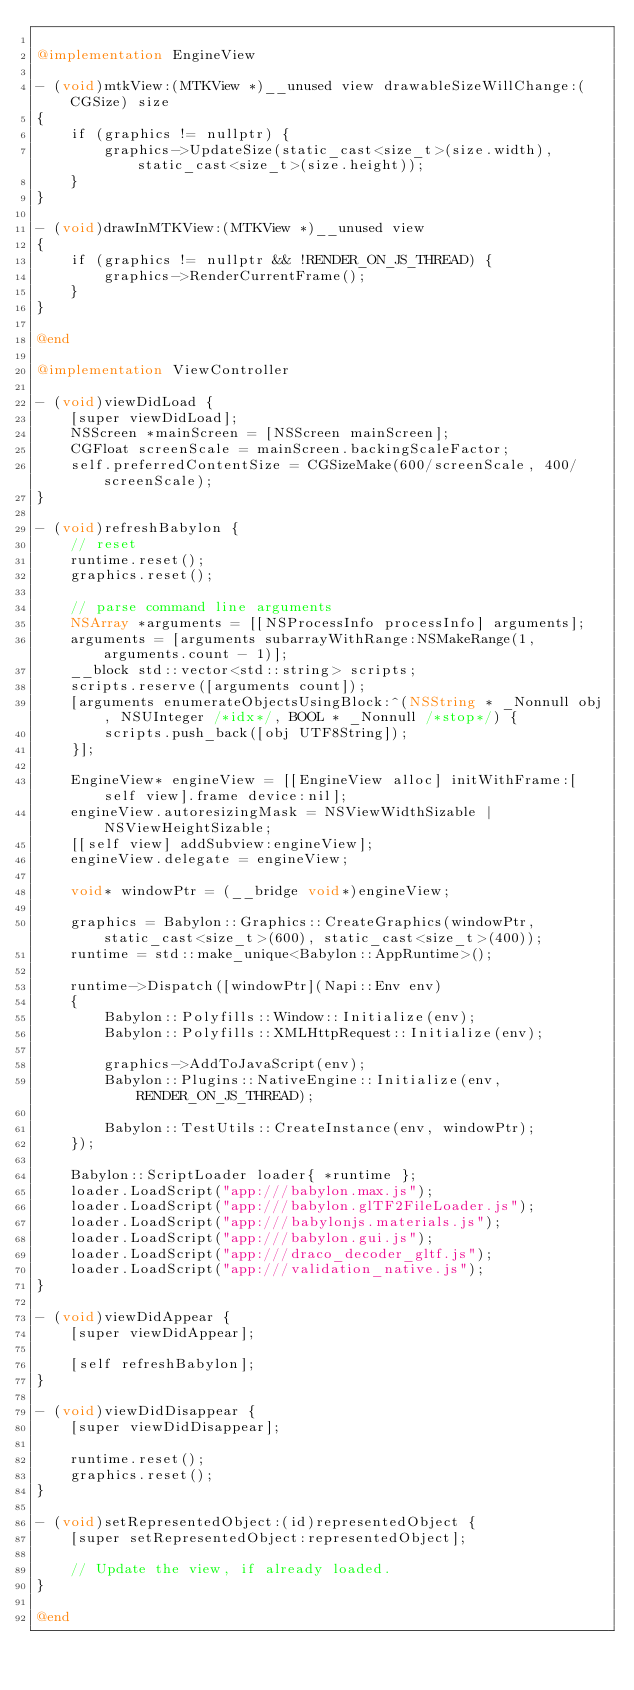<code> <loc_0><loc_0><loc_500><loc_500><_ObjectiveC_>
@implementation EngineView

- (void)mtkView:(MTKView *)__unused view drawableSizeWillChange:(CGSize) size
{
    if (graphics != nullptr) {
        graphics->UpdateSize(static_cast<size_t>(size.width), static_cast<size_t>(size.height));
    }
}

- (void)drawInMTKView:(MTKView *)__unused view
{
    if (graphics != nullptr && !RENDER_ON_JS_THREAD) {
        graphics->RenderCurrentFrame();
    }
}

@end

@implementation ViewController

- (void)viewDidLoad {
    [super viewDidLoad];
    NSScreen *mainScreen = [NSScreen mainScreen];
    CGFloat screenScale = mainScreen.backingScaleFactor;
    self.preferredContentSize = CGSizeMake(600/screenScale, 400/screenScale);
}

- (void)refreshBabylon {
    // reset
    runtime.reset();
    graphics.reset();

    // parse command line arguments
    NSArray *arguments = [[NSProcessInfo processInfo] arguments];
    arguments = [arguments subarrayWithRange:NSMakeRange(1, arguments.count - 1)];
    __block std::vector<std::string> scripts;
    scripts.reserve([arguments count]);
    [arguments enumerateObjectsUsingBlock:^(NSString * _Nonnull obj, NSUInteger /*idx*/, BOOL * _Nonnull /*stop*/) {
        scripts.push_back([obj UTF8String]);
    }];

    EngineView* engineView = [[EngineView alloc] initWithFrame:[self view].frame device:nil];
    engineView.autoresizingMask = NSViewWidthSizable | NSViewHeightSizable;
    [[self view] addSubview:engineView];
    engineView.delegate = engineView;

    void* windowPtr = (__bridge void*)engineView;

    graphics = Babylon::Graphics::CreateGraphics(windowPtr, static_cast<size_t>(600), static_cast<size_t>(400));
    runtime = std::make_unique<Babylon::AppRuntime>();

    runtime->Dispatch([windowPtr](Napi::Env env)
    {
        Babylon::Polyfills::Window::Initialize(env);
        Babylon::Polyfills::XMLHttpRequest::Initialize(env);

        graphics->AddToJavaScript(env);
        Babylon::Plugins::NativeEngine::Initialize(env, RENDER_ON_JS_THREAD);

        Babylon::TestUtils::CreateInstance(env, windowPtr);
    });
    
    Babylon::ScriptLoader loader{ *runtime };
    loader.LoadScript("app:///babylon.max.js");
    loader.LoadScript("app:///babylon.glTF2FileLoader.js");
    loader.LoadScript("app:///babylonjs.materials.js");
    loader.LoadScript("app:///babylon.gui.js");
    loader.LoadScript("app:///draco_decoder_gltf.js");
    loader.LoadScript("app:///validation_native.js");
}

- (void)viewDidAppear {
    [super viewDidAppear];
    
    [self refreshBabylon];
}

- (void)viewDidDisappear {
    [super viewDidDisappear];

    runtime.reset();
    graphics.reset();
}

- (void)setRepresentedObject:(id)representedObject {
    [super setRepresentedObject:representedObject];

    // Update the view, if already loaded.
}

@end
</code> 